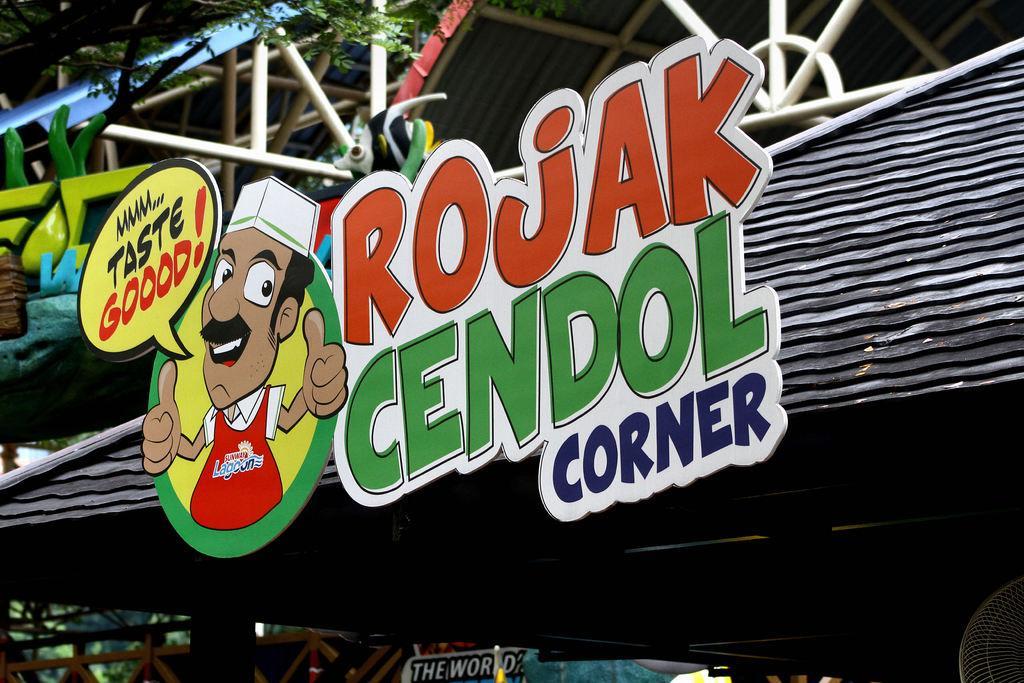Can you describe this image briefly? Here it seems to be a shed. In the middle of the image there is a board attached to the roof. On this board, I can see some text and a cartoon image of a person. At the top of the image there are many metal rods and few leaves are visible. 